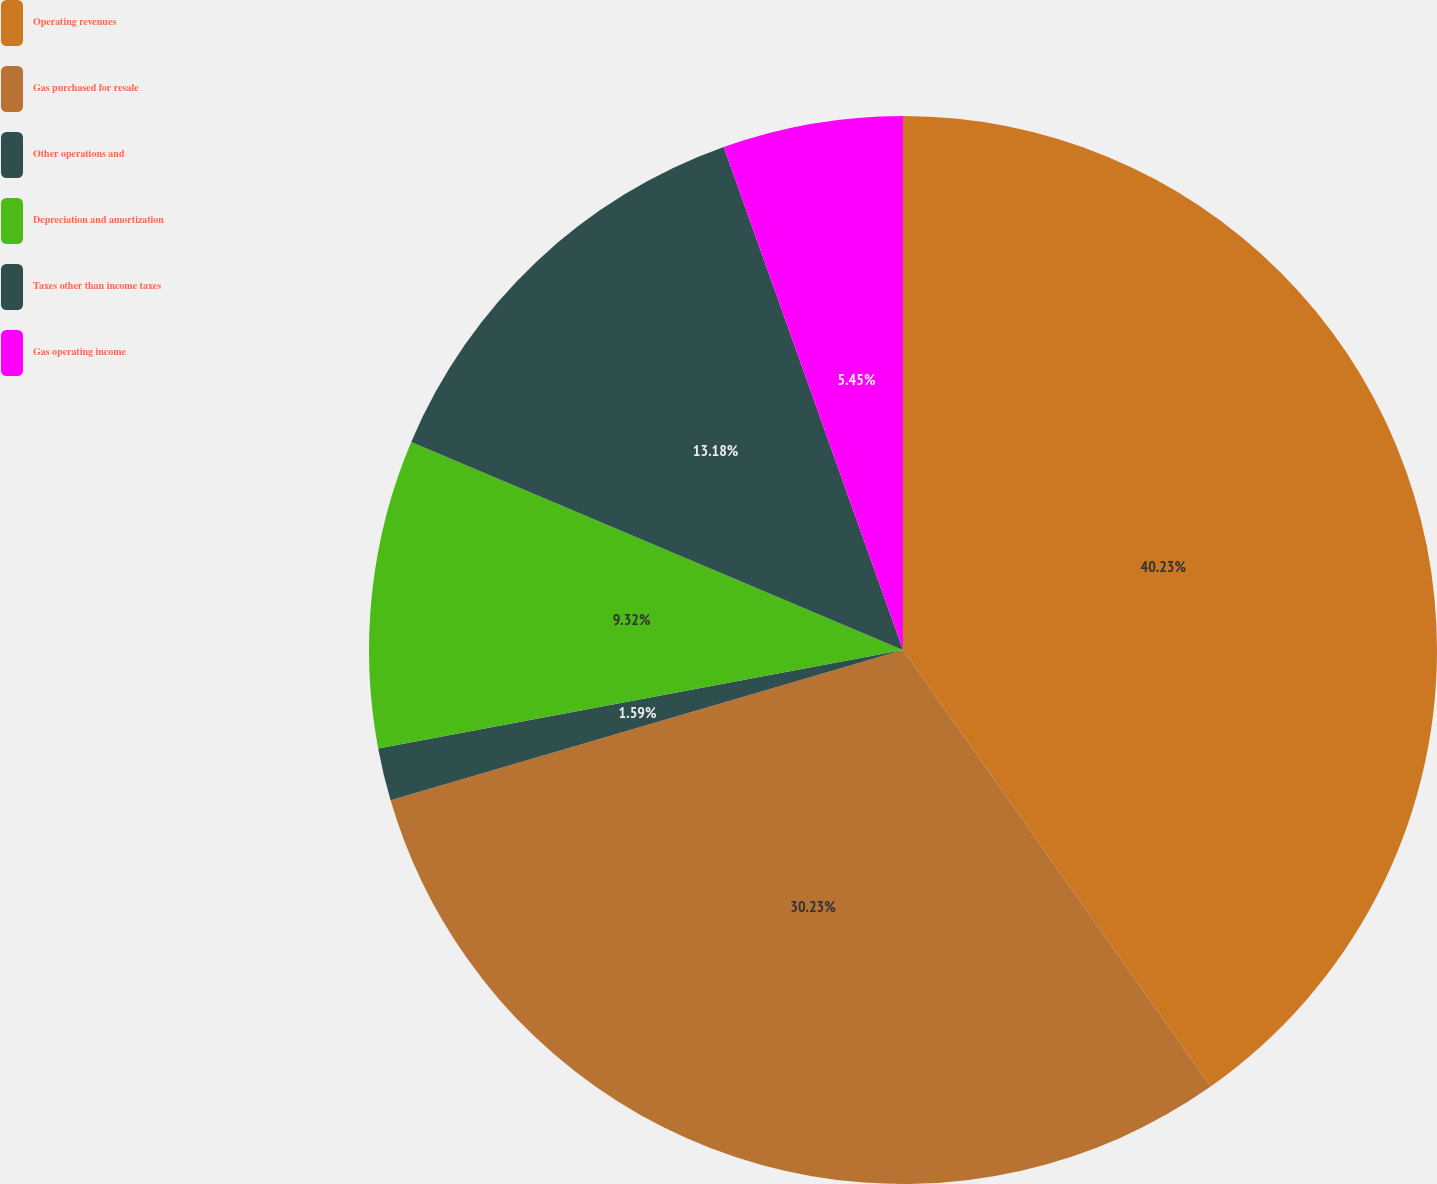Convert chart. <chart><loc_0><loc_0><loc_500><loc_500><pie_chart><fcel>Operating revenues<fcel>Gas purchased for resale<fcel>Other operations and<fcel>Depreciation and amortization<fcel>Taxes other than income taxes<fcel>Gas operating income<nl><fcel>40.23%<fcel>30.23%<fcel>1.59%<fcel>9.32%<fcel>13.18%<fcel>5.45%<nl></chart> 